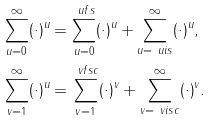<formula> <loc_0><loc_0><loc_500><loc_500>\sum _ { u = 0 } ^ { \infty } ( \cdot ) ^ { u } & = \sum _ { u = 0 } ^ { \ u f s } ( \cdot ) ^ { u } + \sum _ { u = \ u i s } ^ { \infty } ( \cdot ) ^ { u } , \\ \sum _ { v = 1 } ^ { \infty } ( \cdot ) ^ { u } & = \sum _ { v = 1 } ^ { \ v f s c } ( \cdot ) ^ { v } + \sum _ { v = \ v i s c } ^ { \infty } ( \cdot ) ^ { v } .</formula> 